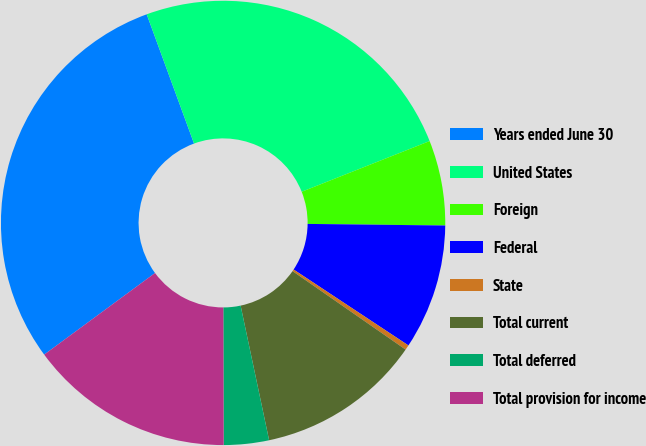Convert chart to OTSL. <chart><loc_0><loc_0><loc_500><loc_500><pie_chart><fcel>Years ended June 30<fcel>United States<fcel>Foreign<fcel>Federal<fcel>State<fcel>Total current<fcel>Total deferred<fcel>Total provision for income<nl><fcel>29.51%<fcel>24.58%<fcel>6.19%<fcel>9.11%<fcel>0.36%<fcel>12.02%<fcel>3.28%<fcel>14.94%<nl></chart> 